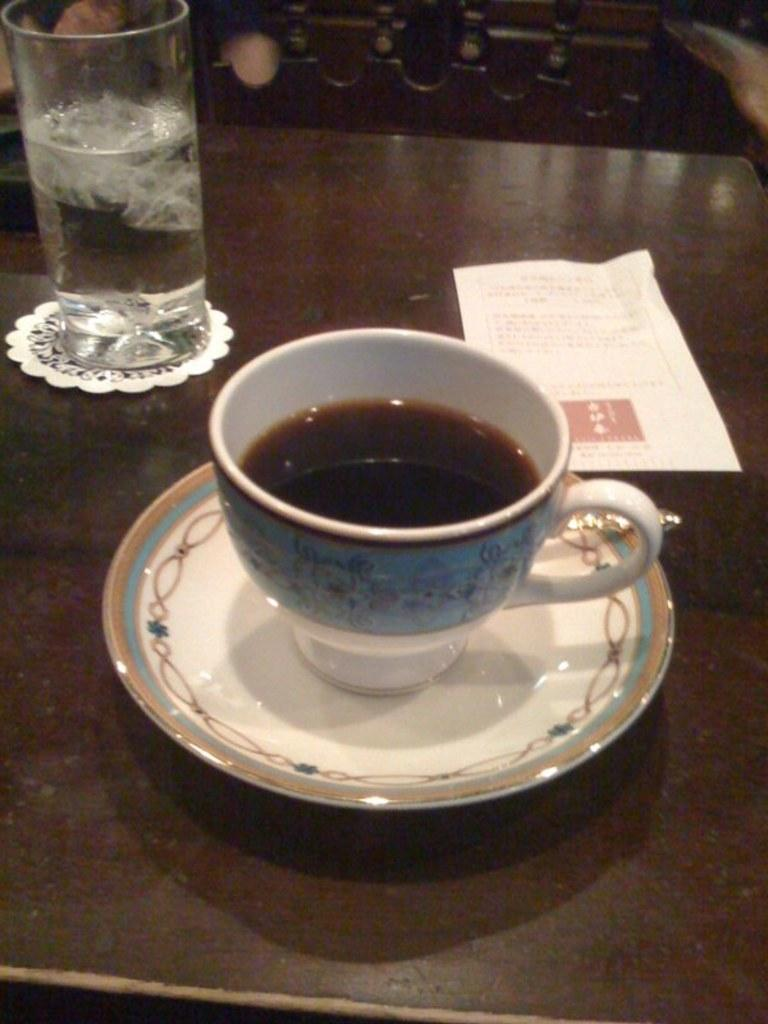What is in the cup that is visible in the image? There is a cup with liquid in the image. What is placed under the cup in the image? There is a saucer in the image. What type of object is made of paper in the image? There is a paper in the image. What other objects can be seen on the surface in the image? There are other objects on the surface in the image. What type of objects can be seen in the background of the image? There are wooden objects in the background of the image. What type of humor can be seen in the image? There is no humor present in the image; it is a still image of objects. What type of lace is used to decorate the wooden objects in the image? There is no lace present in the image; the wooden objects are plain. 